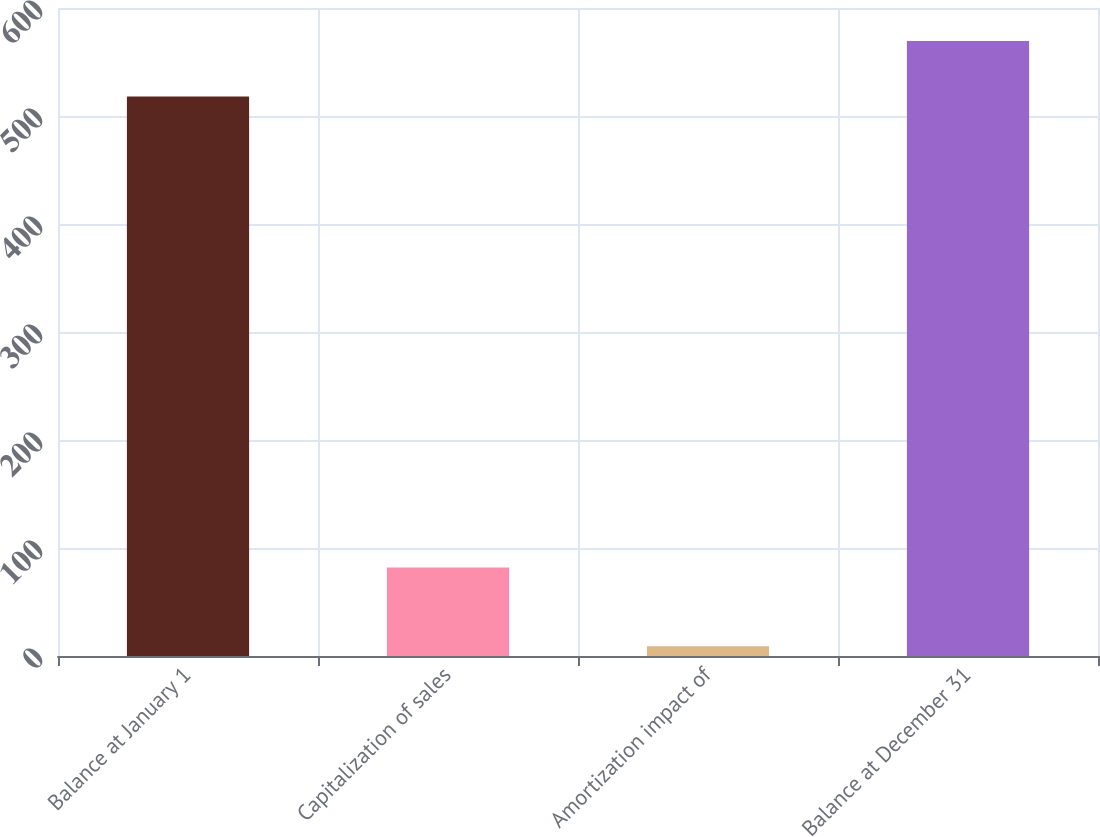Convert chart to OTSL. <chart><loc_0><loc_0><loc_500><loc_500><bar_chart><fcel>Balance at January 1<fcel>Capitalization of sales<fcel>Amortization impact of<fcel>Balance at December 31<nl><fcel>518<fcel>82<fcel>9<fcel>569.5<nl></chart> 